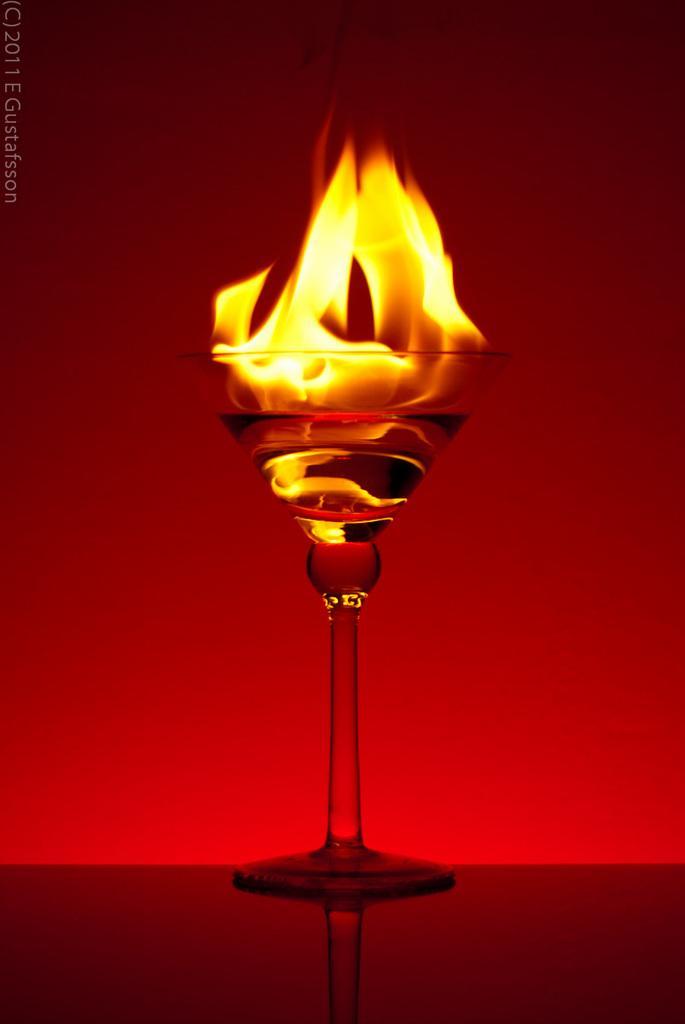Can you describe this image briefly? There is a fire in the glass which is placed on a surface. On the top left, there is a watermark. And the background is red in color. 